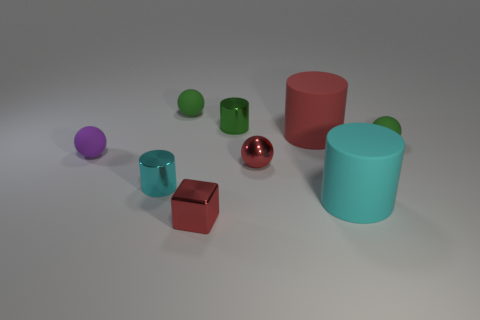Subtract all small red spheres. How many spheres are left? 3 Subtract all cylinders. How many objects are left? 5 Subtract all green cylinders. How many cylinders are left? 3 Subtract 1 blocks. How many blocks are left? 0 Subtract all gray spheres. How many cyan blocks are left? 0 Subtract 1 green spheres. How many objects are left? 8 Subtract all brown balls. Subtract all green cubes. How many balls are left? 4 Subtract all tiny yellow rubber balls. Subtract all tiny metal objects. How many objects are left? 5 Add 8 cyan cylinders. How many cyan cylinders are left? 10 Add 8 purple objects. How many purple objects exist? 9 